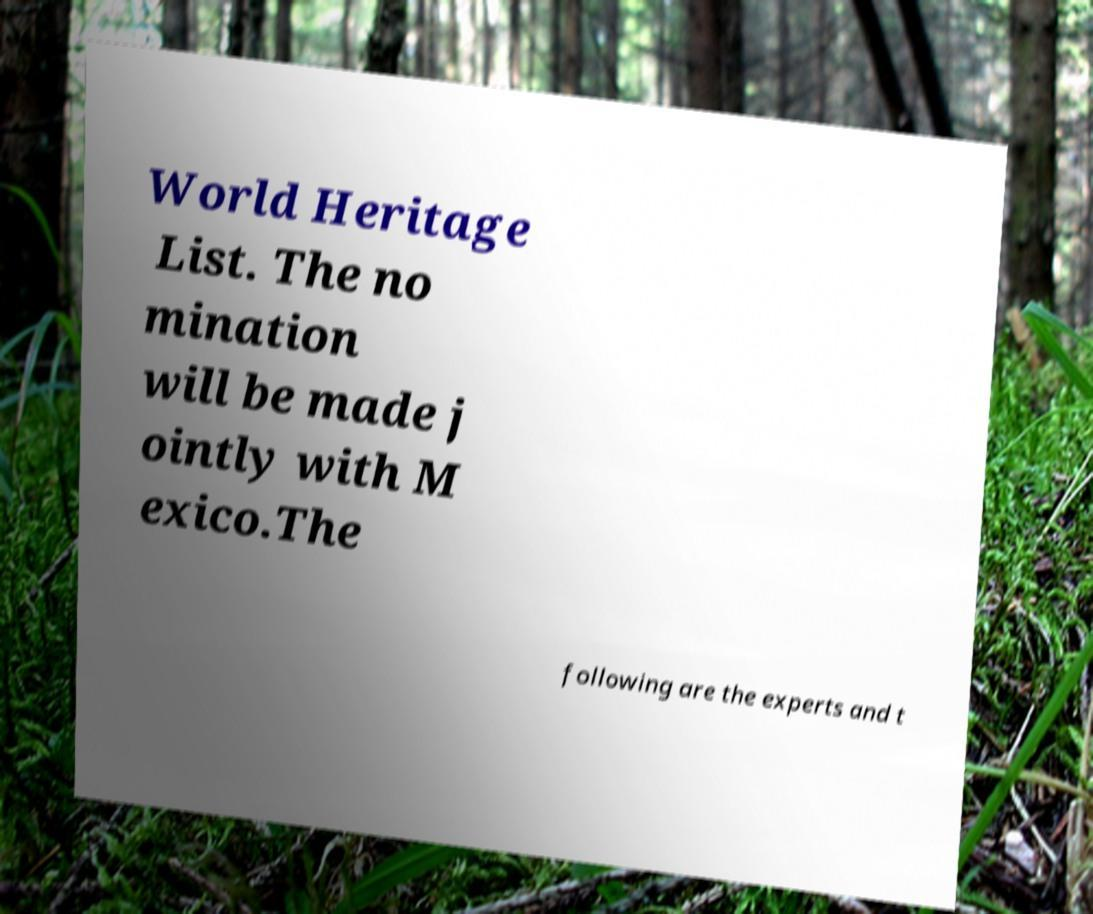There's text embedded in this image that I need extracted. Can you transcribe it verbatim? World Heritage List. The no mination will be made j ointly with M exico.The following are the experts and t 